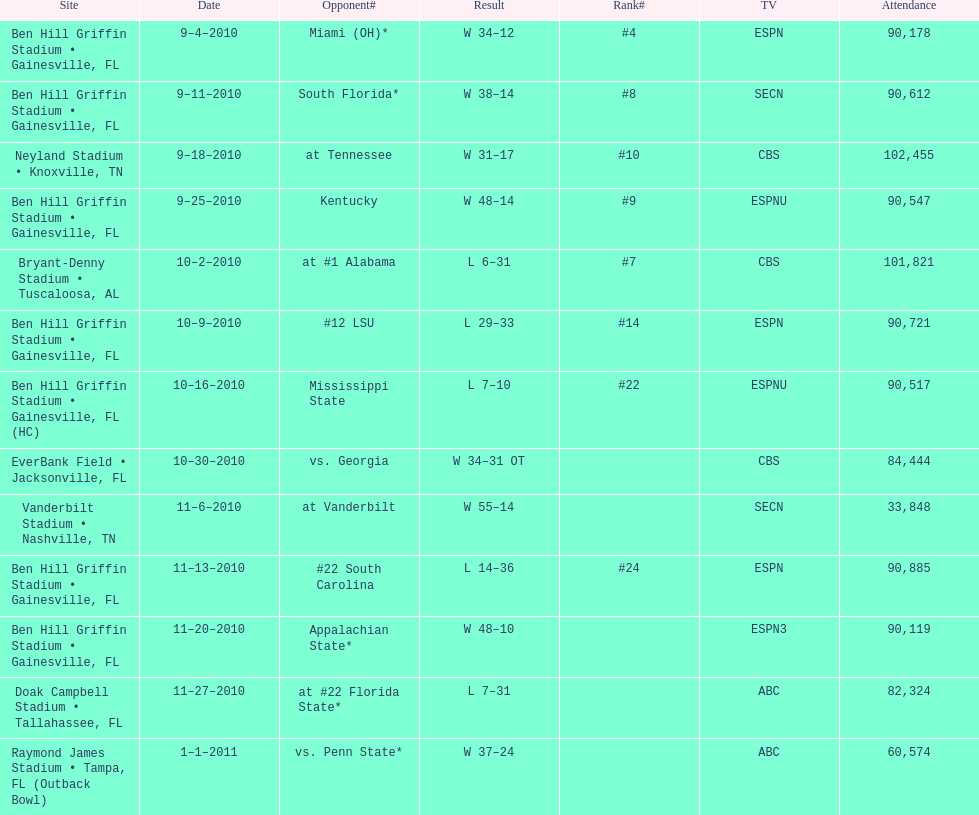Give me the full table as a dictionary. {'header': ['Site', 'Date', 'Opponent#', 'Result', 'Rank#', 'TV', 'Attendance'], 'rows': [['Ben Hill Griffin Stadium • Gainesville, FL', '9–4–2010', 'Miami (OH)*', 'W\xa034–12', '#4', 'ESPN', '90,178'], ['Ben Hill Griffin Stadium • Gainesville, FL', '9–11–2010', 'South Florida*', 'W\xa038–14', '#8', 'SECN', '90,612'], ['Neyland Stadium • Knoxville, TN', '9–18–2010', 'at\xa0Tennessee', 'W\xa031–17', '#10', 'CBS', '102,455'], ['Ben Hill Griffin Stadium • Gainesville, FL', '9–25–2010', 'Kentucky', 'W\xa048–14', '#9', 'ESPNU', '90,547'], ['Bryant-Denny Stadium • Tuscaloosa, AL', '10–2–2010', 'at\xa0#1\xa0Alabama', 'L\xa06–31', '#7', 'CBS', '101,821'], ['Ben Hill Griffin Stadium • Gainesville, FL', '10–9–2010', '#12\xa0LSU', 'L\xa029–33', '#14', 'ESPN', '90,721'], ['Ben Hill Griffin Stadium • Gainesville, FL (HC)', '10–16–2010', 'Mississippi State', 'L\xa07–10', '#22', 'ESPNU', '90,517'], ['EverBank Field • Jacksonville, FL', '10–30–2010', 'vs.\xa0Georgia', 'W\xa034–31\xa0OT', '', 'CBS', '84,444'], ['Vanderbilt Stadium • Nashville, TN', '11–6–2010', 'at\xa0Vanderbilt', 'W\xa055–14', '', 'SECN', '33,848'], ['Ben Hill Griffin Stadium • Gainesville, FL', '11–13–2010', '#22\xa0South Carolina', 'L\xa014–36', '#24', 'ESPN', '90,885'], ['Ben Hill Griffin Stadium • Gainesville, FL', '11–20–2010', 'Appalachian State*', 'W\xa048–10', '', 'ESPN3', '90,119'], ['Doak Campbell Stadium • Tallahassee, FL', '11–27–2010', 'at\xa0#22\xa0Florida State*', 'L\xa07–31', '', 'ABC', '82,324'], ['Raymond James Stadium • Tampa, FL (Outback Bowl)', '1–1–2011', 'vs.\xa0Penn State*', 'W\xa037–24', '', 'ABC', '60,574']]} How many games were played at the ben hill griffin stadium during the 2010-2011 season? 7. 